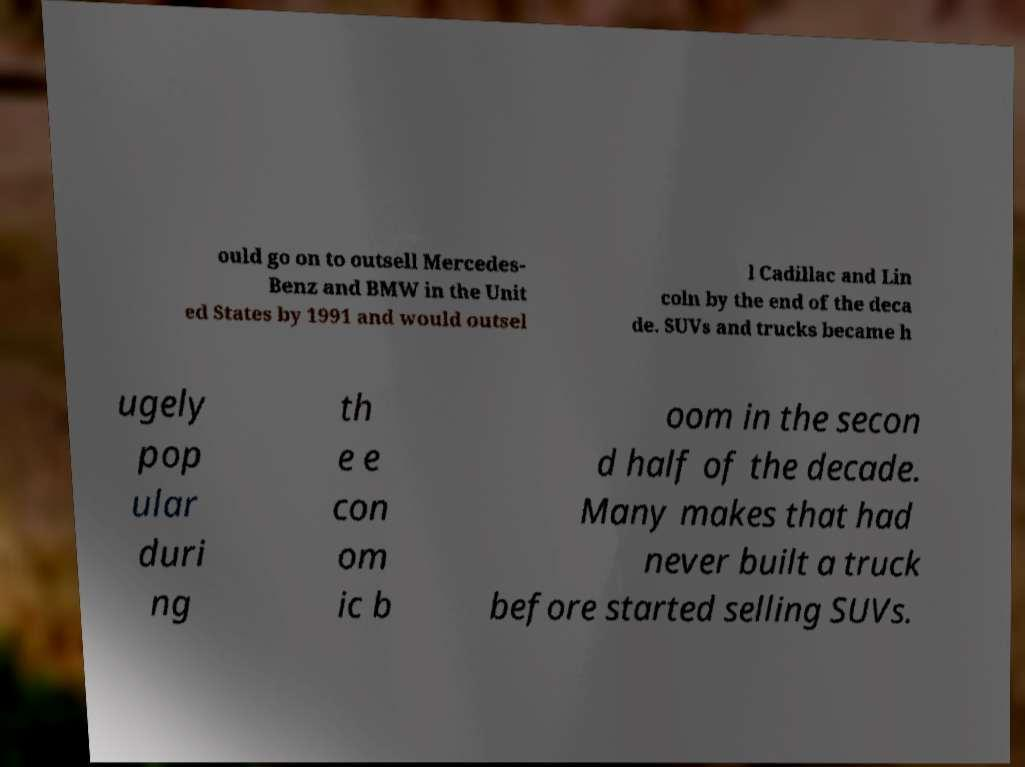Can you read and provide the text displayed in the image?This photo seems to have some interesting text. Can you extract and type it out for me? ould go on to outsell Mercedes- Benz and BMW in the Unit ed States by 1991 and would outsel l Cadillac and Lin coln by the end of the deca de. SUVs and trucks became h ugely pop ular duri ng th e e con om ic b oom in the secon d half of the decade. Many makes that had never built a truck before started selling SUVs. 